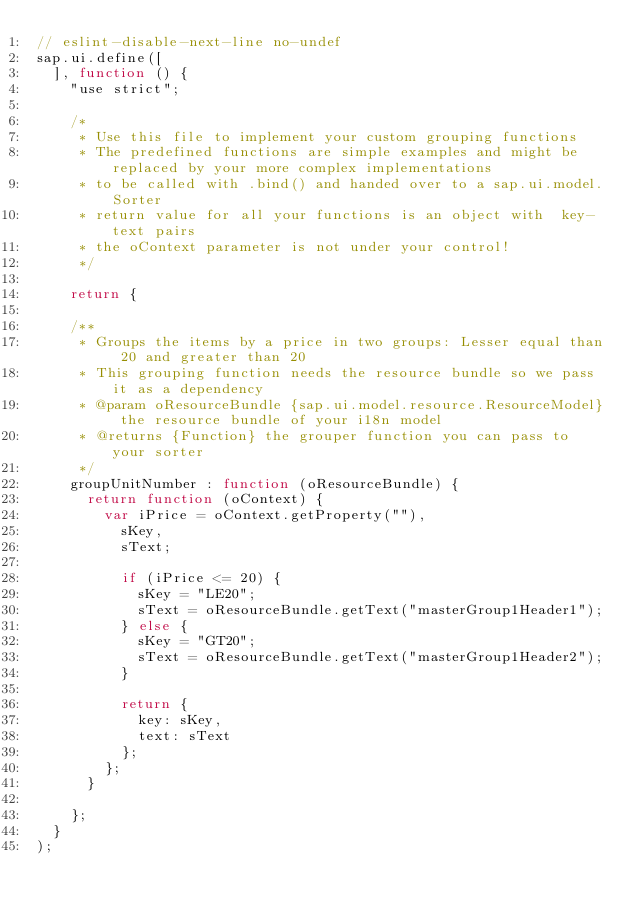Convert code to text. <code><loc_0><loc_0><loc_500><loc_500><_JavaScript_>// eslint-disable-next-line no-undef
sap.ui.define([
	], function () {
		"use strict";

		/*
		 * Use this file to implement your custom grouping functions
		 * The predefined functions are simple examples and might be replaced by your more complex implementations
		 * to be called with .bind() and handed over to a sap.ui.model.Sorter
		 * return value for all your functions is an object with  key-text pairs
		 * the oContext parameter is not under your control!
		 */

		return {

		/**
		 * Groups the items by a price in two groups: Lesser equal than 20 and greater than 20
		 * This grouping function needs the resource bundle so we pass it as a dependency
		 * @param oResourceBundle {sap.ui.model.resource.ResourceModel} the resource bundle of your i18n model
		 * @returns {Function} the grouper function you can pass to your sorter
		 */
		groupUnitNumber : function (oResourceBundle) {
			return function (oContext) {
				var iPrice = oContext.getProperty(""),
					sKey,
					sText;

					if (iPrice <= 20) {
						sKey = "LE20";
						sText = oResourceBundle.getText("masterGroup1Header1");
					} else {
						sKey = "GT20";
						sText = oResourceBundle.getText("masterGroup1Header2");
					}

					return {
						key: sKey,
						text: sText
					};
				};
			}

		};
	}
);</code> 